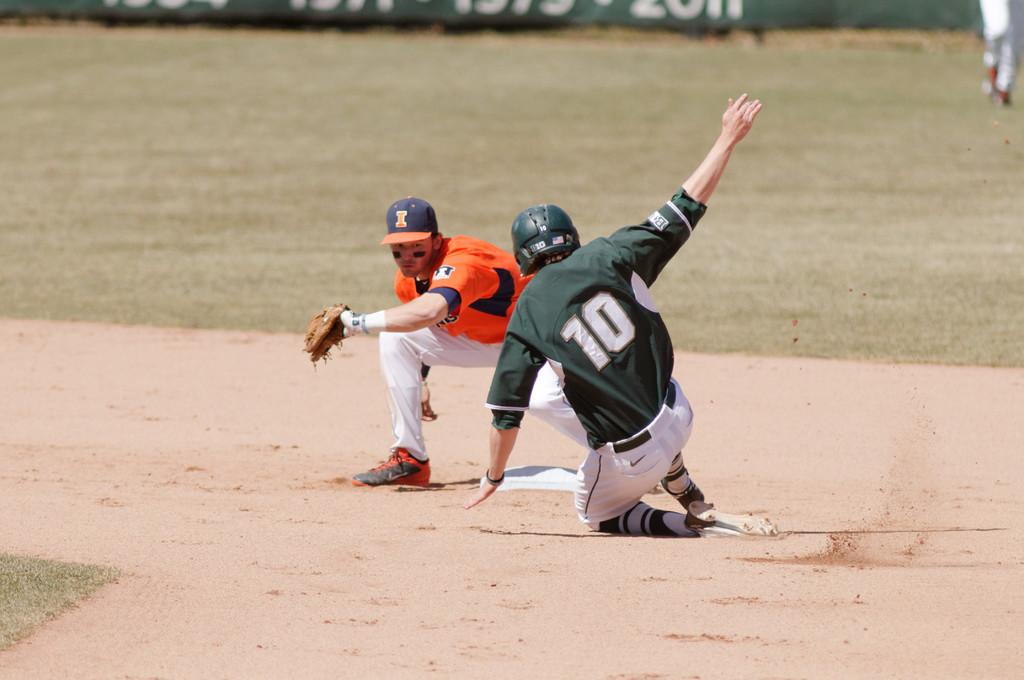<image>
Create a compact narrative representing the image presented. A baseball player wearing a green and white uniform and the number 10 slides into base. 